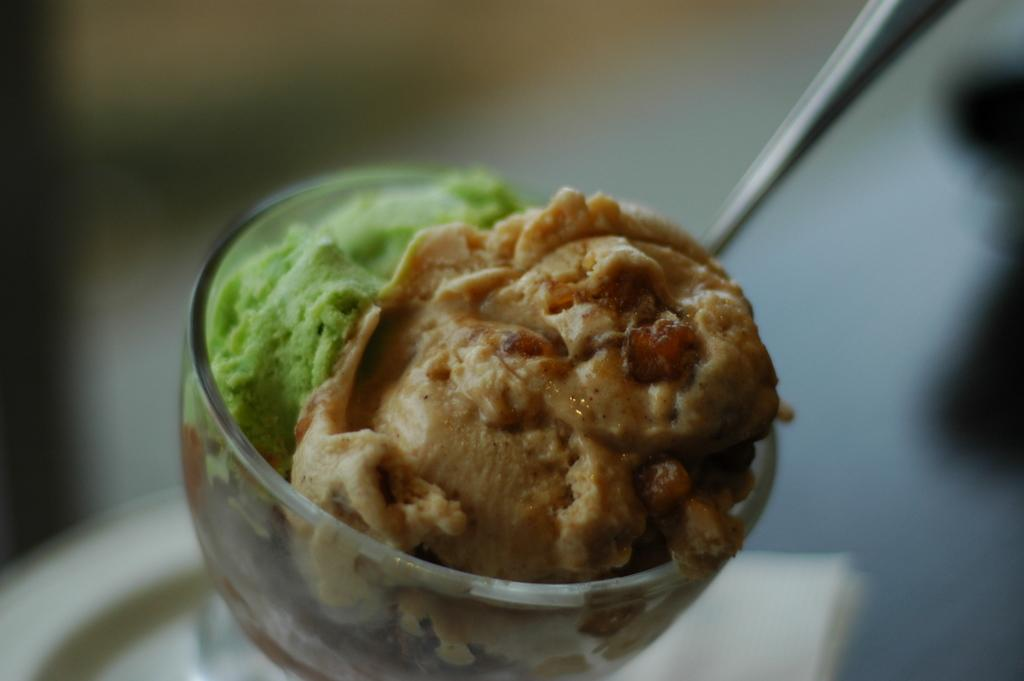What type of dessert is in the image? There is ice cream in a cup in the image. What utensil is visible in the image? There is a spoon visible in the image. What type of kitty can be seen playing with the birds in the image? There are no kitties or birds present in the image; it only features ice cream in a cup and a spoon. 